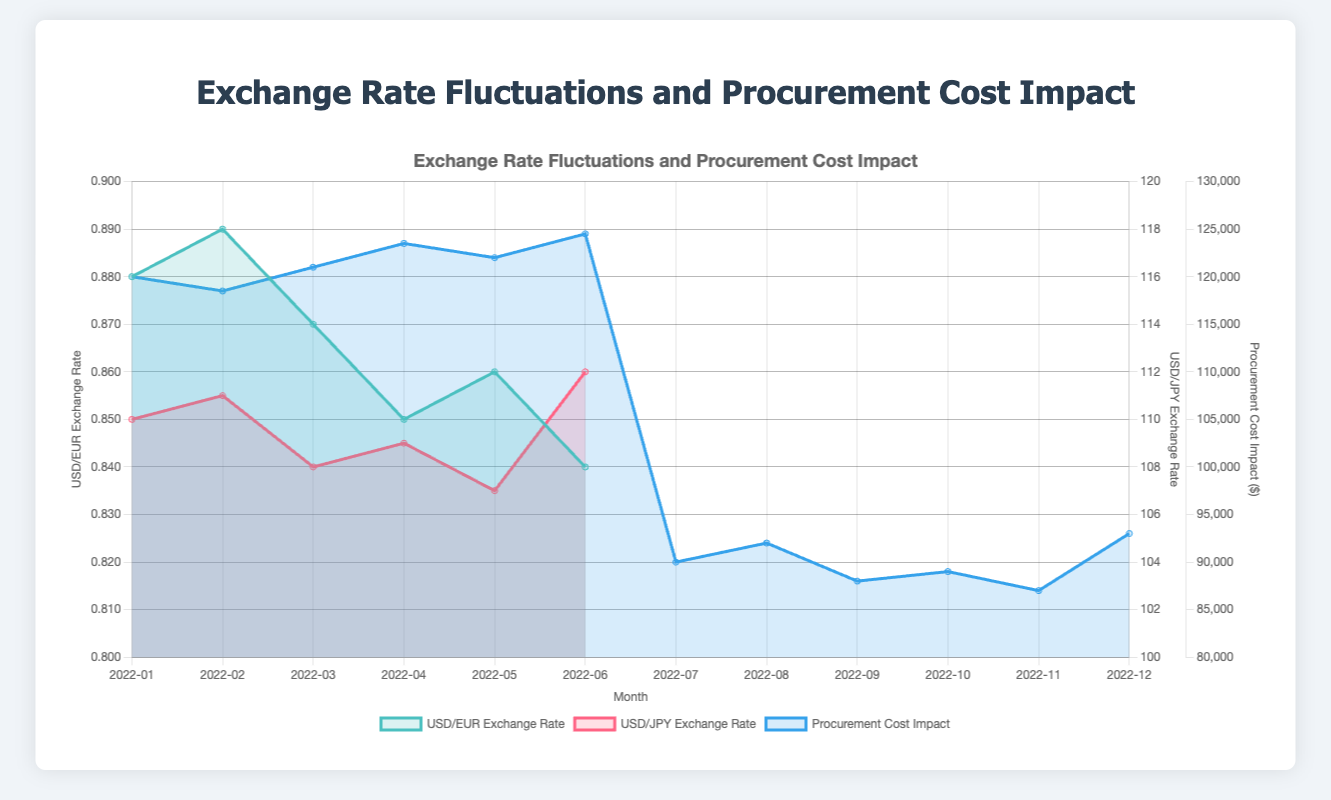What is the title of the chart? The title of the chart is displayed at the top center and reads "Exchange Rate Fluctuations and Procurement Cost Impact".
Answer: Exchange Rate Fluctuations and Procurement Cost Impact How many data points are shown for the USD/EUR exchange rate? The chart's line representing USD/EUR exchange rate has six data points, corresponding to the months from January 2022 to June 2022.
Answer: 6 Which currency pair shows a higher average exchange rate in any given month, USD/EUR or USD/JPY? Reviewing the two lines representing USD/EUR and USD/JPY exchange rates, USD/JPY consistently shows a higher average exchange rate compared to USD/EUR.
Answer: USD/JPY What is the highest procurement cost impact recorded, and in which month did it occur? The highest procurement cost impact is identified by finding the peak in the dark blue area, which corresponds to $124500 and occurred in June 2022.
Answer: June 2022, $124500 How does the procurement cost impact change when the USD/JPY exchange rate peaks? The peak of the USD/JPY exchange rate occurs in December 2022. During this month, the procurement cost impact also reaches a high value of $93000, indicating a potential correlation.
Answer: The procurement cost impact increases What is the average procurement cost impact for the USD/EUR data points? Summing up the procurement costs for USD/EUR into a \( S = 120000 + 118500 + 121000 + 123500 + 122000 + 124500 = 729500 \), the number of points \( n = 6 \). Therefore, the average is \( \frac{S}{n} = \frac{729500}{6} = 121583.33 \).
Answer: $121583.33 During which month(s) did the USD/JPY exchange rate decrease compared to the previous month? Observing the red line denoting USD/JPY exchange rates, the rate decreases in September (from August to September), October (from September to October), and November (from October to November).
Answer: September, October, November Is there a month where both procurement cost impact and USD/EUR exchange rate are at their peak? The peaks of procurement cost impact (June 2022) and the USD/EUR exchange rate (January and February 2022) do not coincide - indicating no overlapping peak for both metrics.
Answer: No Which currency pair exhibits more volatility in the exchange rates and how can you tell? The USD/JPY exchange rate exhibits more volatility; this is evident from the greater fluctuation range compared to USD/EUR, as indicated by the steeper slopes and more frequent changes in direction of the red line.
Answer: USD/JPY 